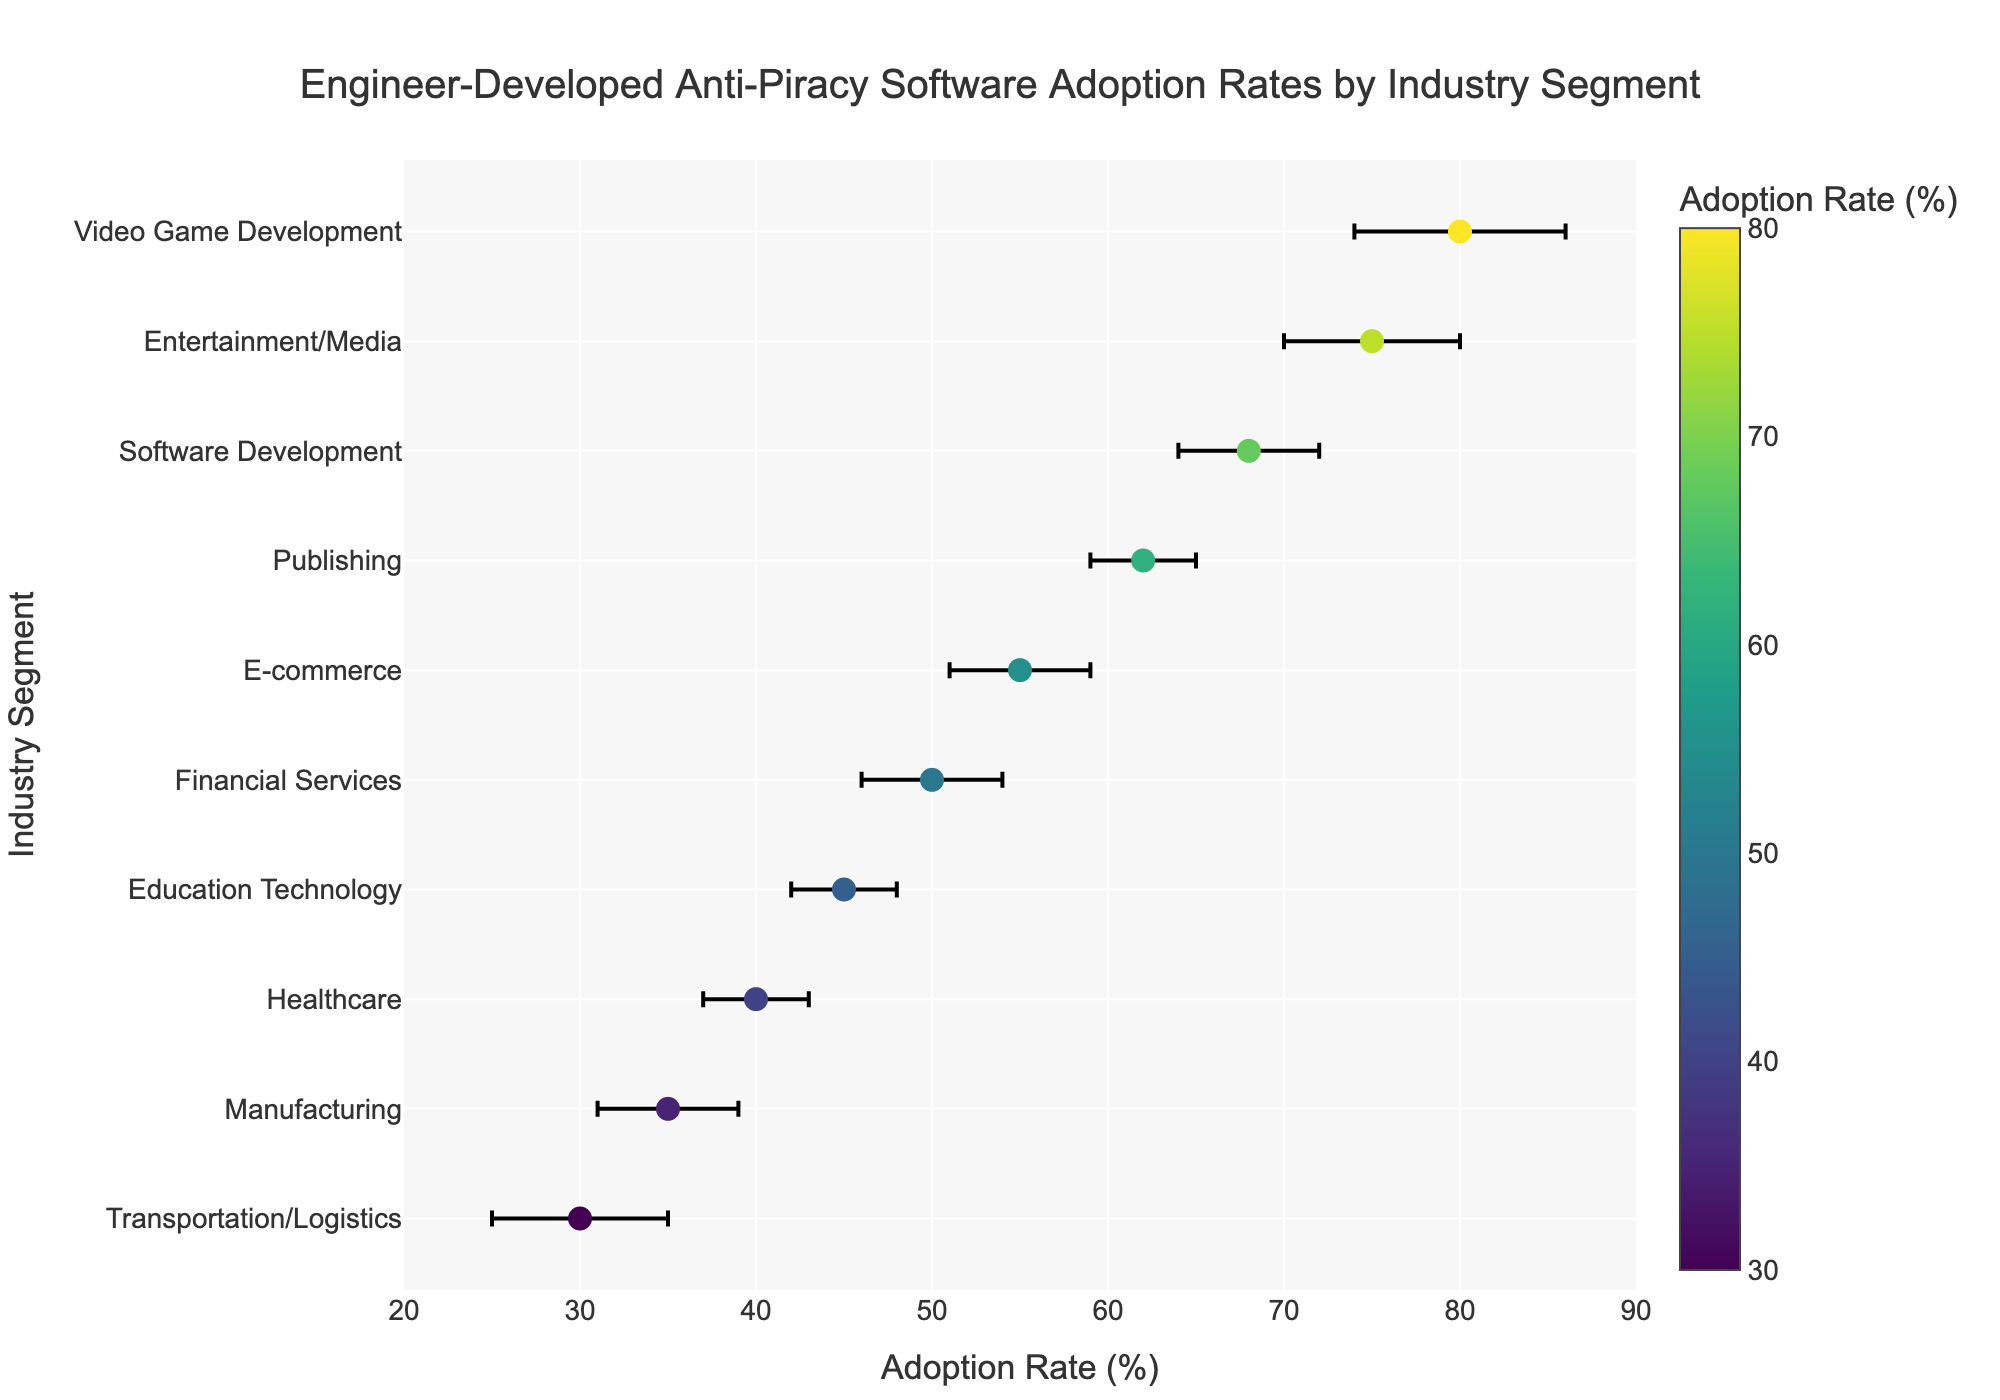What is the title of the figure? The title is explicitly mentioned at the top of the figure, and it provides a summary of what the figure is about.
Answer: Engineer-Developed Anti-Piracy Software Adoption Rates by Industry Segment What is the Adoption Rate for the Entertainment/Media segment? You can determine this by looking at the dot corresponding to the Entertainment/Media segment on the y-axis and reading off the x-axis value.
Answer: 75% Which industry segment has the highest Adoption Rate? Identify the highest dot on the x-axis and trace it to the corresponding industry segment on the y-axis.
Answer: Video Game Development What's the range of the Adoption Rates displayed in the figure? The range is found by identifying the maximum and minimum Adoption Rates displayed on the x-axis. The highest rate is 80% for Video Game Development, and the lowest is 30% for Transportation/Logistics.
Answer: 30% to 80% How many industry segments have an Adoption Rate of 50% or higher? Count the number of dots on the plot with x-values (Adoption Rates) greater than or equal to 50%.
Answer: 6 What is the Standard Error for the Healthcare segment? Look for the dot corresponding to Healthcare and read off its error bar length on the x-axis which represents the Standard Error.
Answer: 3% Which segment has the smallest Standard Error, and what is it? Identify which error bar is the shortest on the x-axis and match it to its corresponding y-axis industry segment. Then, read off the Standard Error value from the error bar's length.
Answer: Publishing, 3% By how much does the Adoption Rate of Software Development exceed that of Financial Services? Subtract the Adoption Rate of Financial Services (50%) from that of Software Development (68%).
Answer: 18% What is the average Standard Error across all industry segments? Sum the Standard Errors for all industry segments from the data table and divide by the number of industry segments (10).
Answer: 4.1% Which industry segment has the lowest Adoption Rate, and what does it highlight about anti-piracy software adoption in that segment? Identify the lowest dot on the plot and read the corresponding industry segment on the y-axis, discussing what this might imply for anti-piracy software uptake in that industry.
Answer: Transportation/Logistics, indicating lower emphasis or need for anti-piracy measures in this segment 